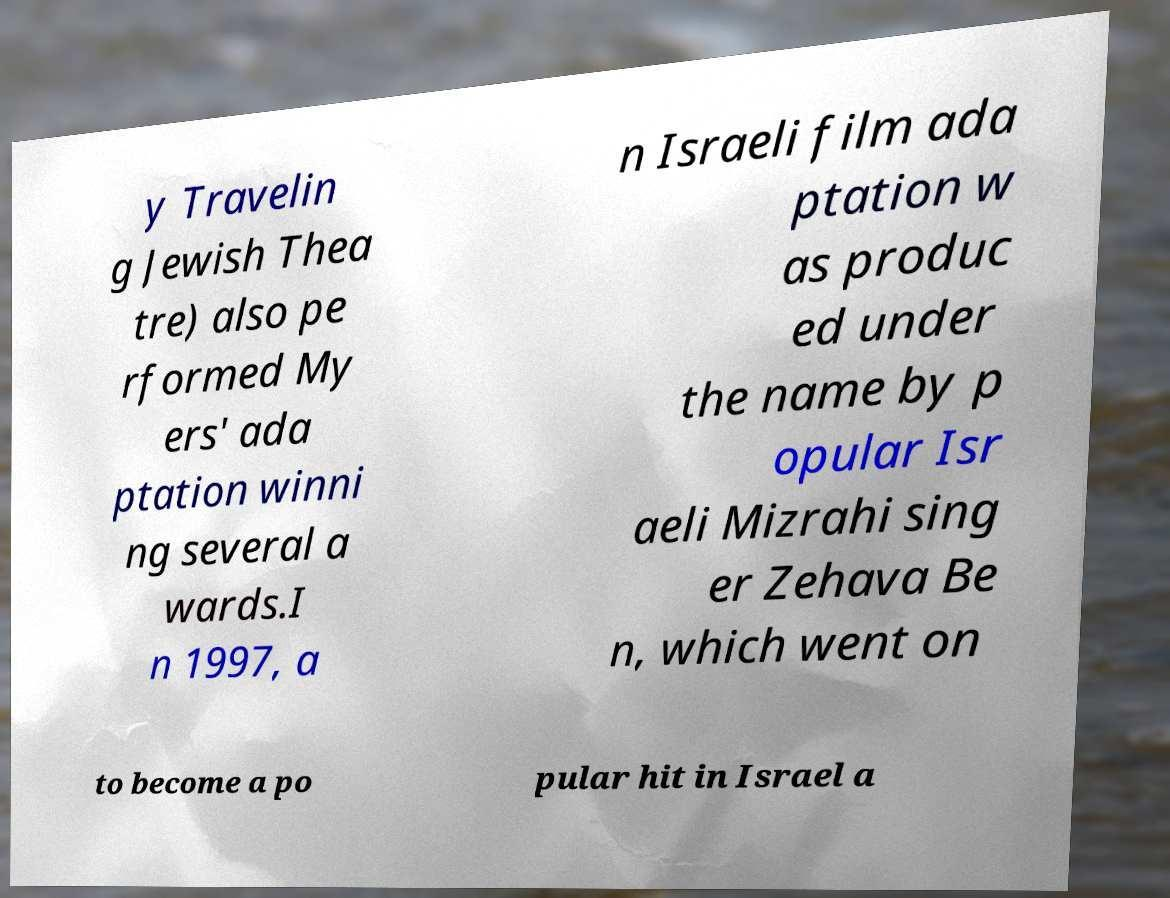For documentation purposes, I need the text within this image transcribed. Could you provide that? y Travelin g Jewish Thea tre) also pe rformed My ers' ada ptation winni ng several a wards.I n 1997, a n Israeli film ada ptation w as produc ed under the name by p opular Isr aeli Mizrahi sing er Zehava Be n, which went on to become a po pular hit in Israel a 